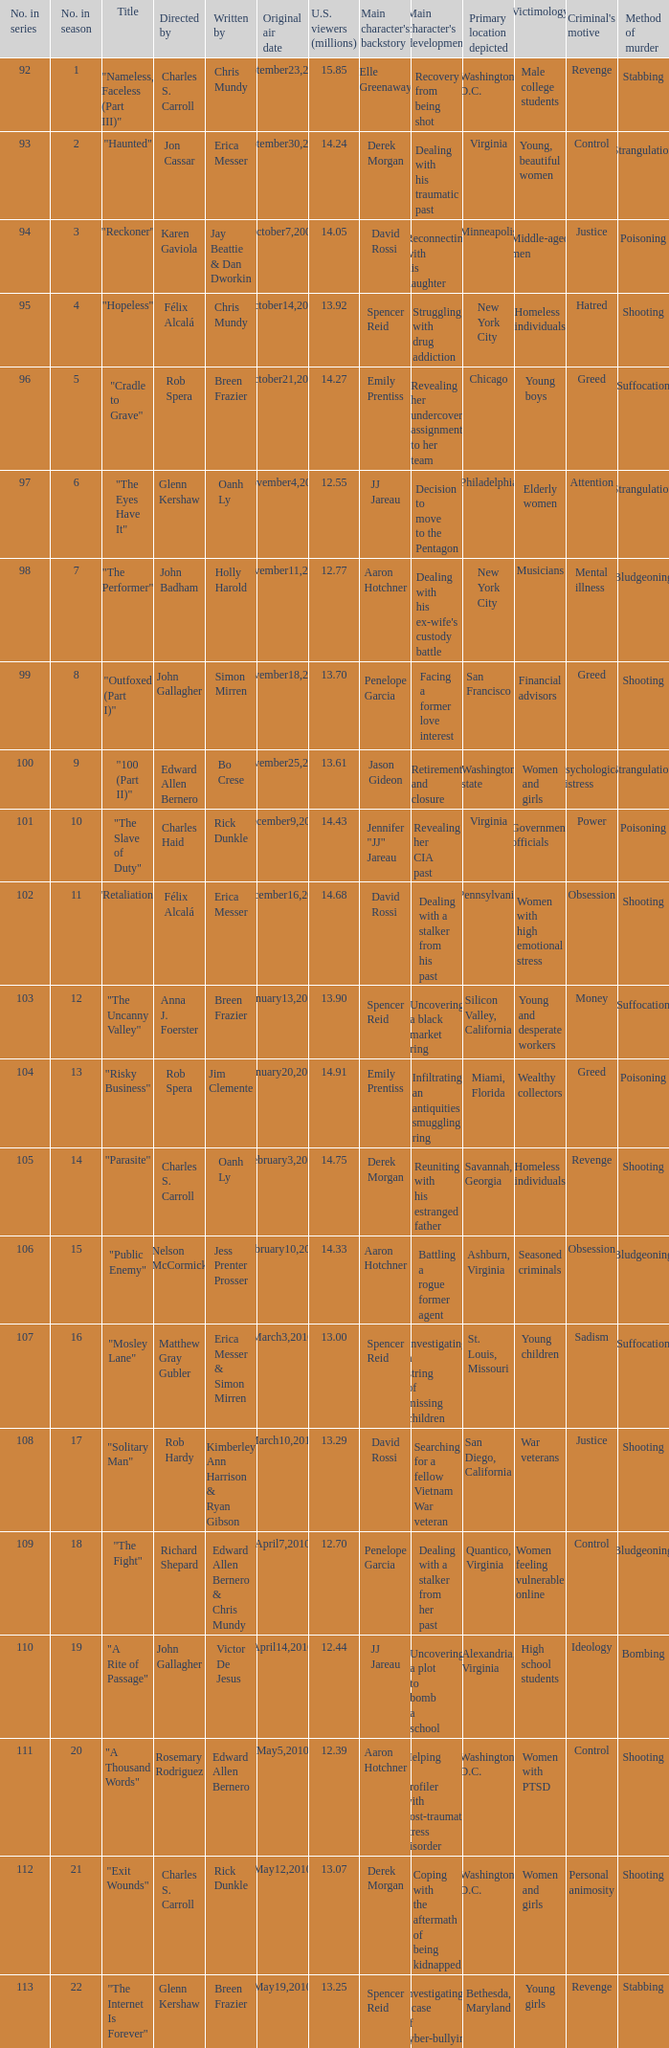What was the original air date for the episode with 13.92 million us viewers? October14,2009. 